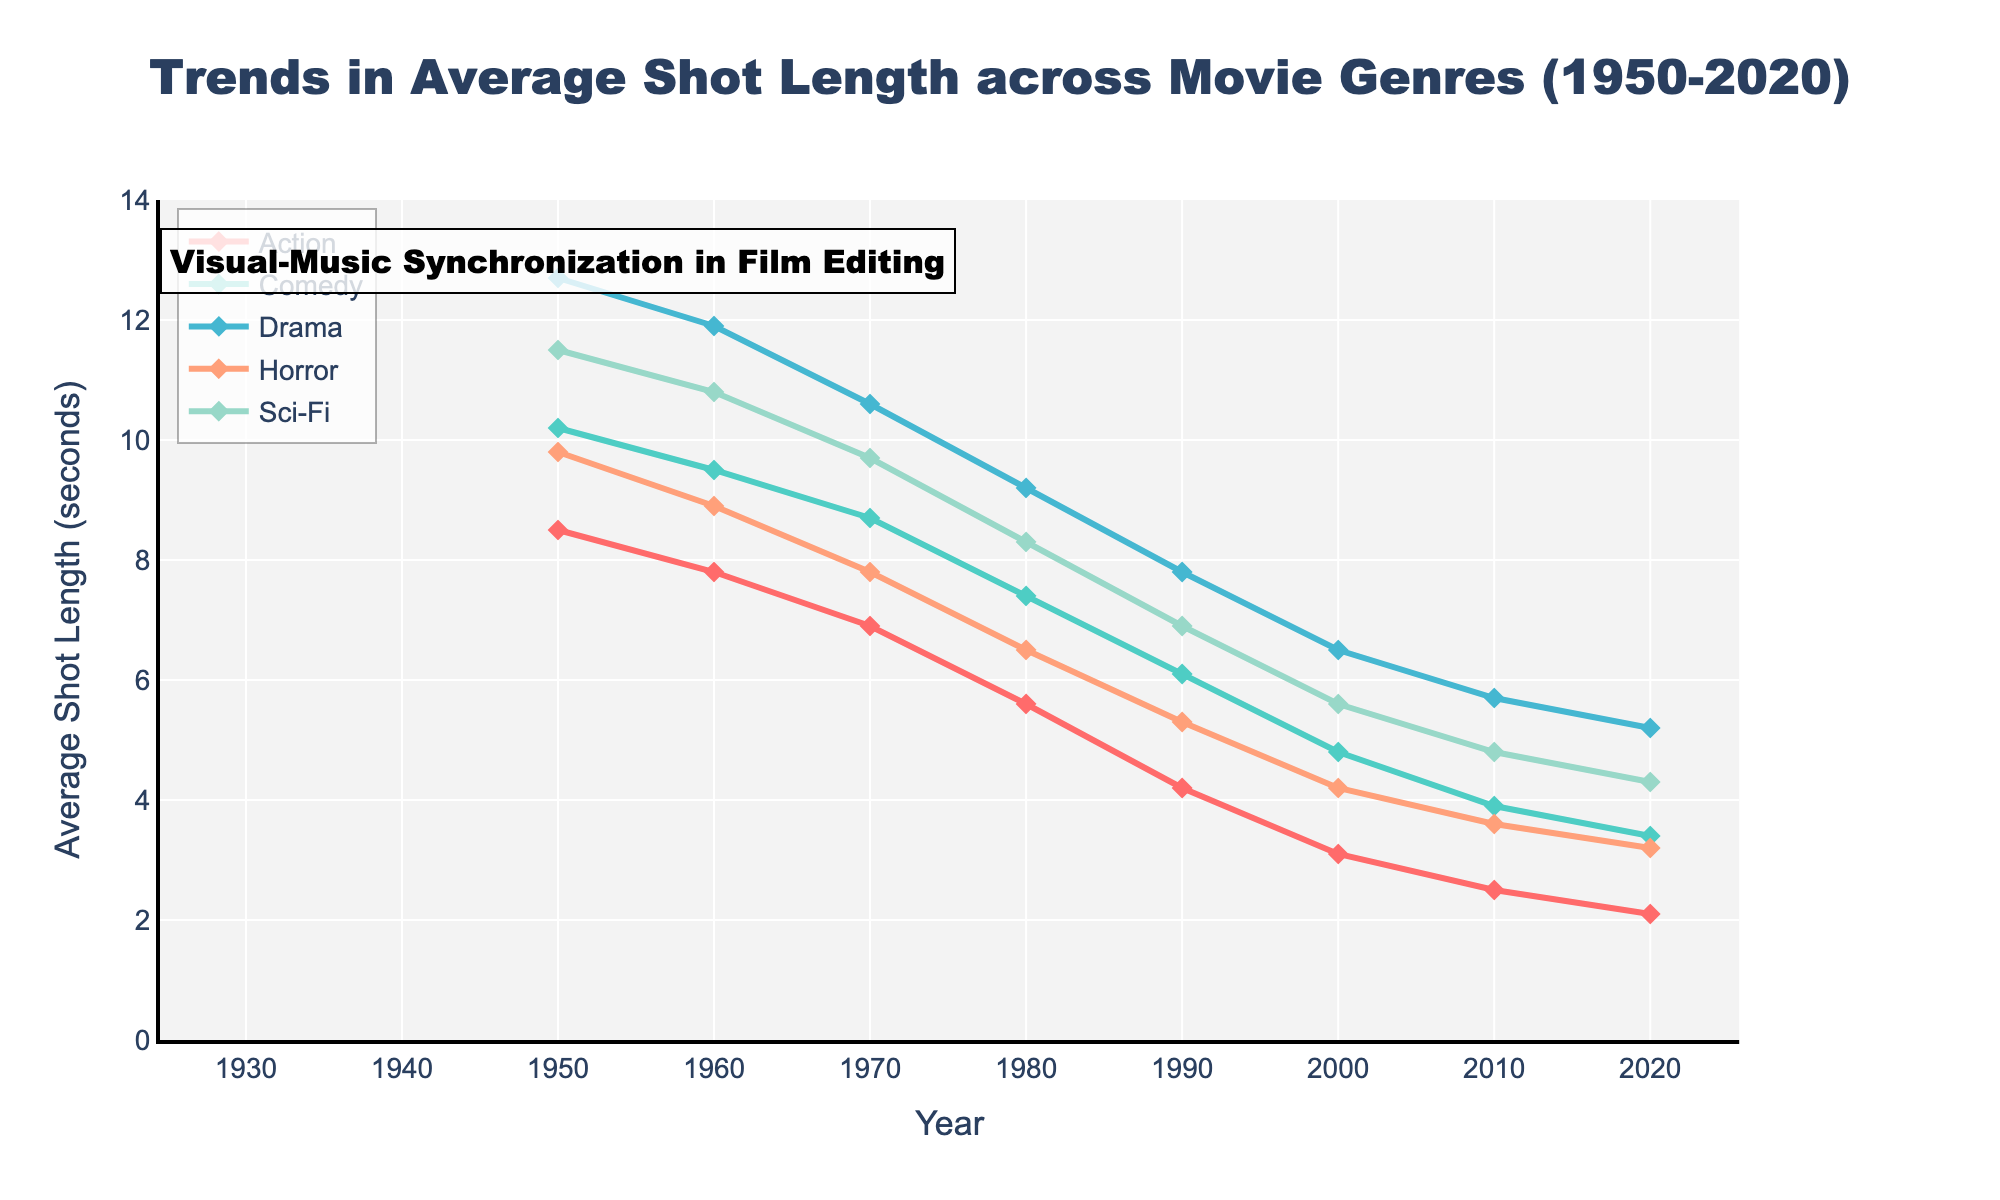How has the average shot length in Action movies changed from 1950 to 2020? From 1950 to 2020, the average shot length in Action movies has decreased from 8.5 seconds to 2.1 seconds. By subtracting the two values, we see a decline of 6.4 seconds.
Answer: Decreased by 6.4 seconds Which genre had the shortest average shot length in 2020? In 2020, the average shot length for Action movies was 2.1 seconds, whereas Comedy was 3.4, Drama was 5.2, Horror was 3.2, and Sci-Fi was 4.3 seconds. The shortest is 2.1 seconds in Action.
Answer: Action What is the difference in average shot length between Drama and Horror movies in 1990? In 1990, the average shot length for Drama movies was 7.8 seconds and for Horror movies, it was 5.3 seconds. The difference is 7.8 - 5.3 = 2.5 seconds.
Answer: 2.5 seconds What trend can you observe in the average shot length for Sci-Fi movies from 1950 to 2020? From 1950 to 2020, the average shot length for Sci-Fi movies has gradually decreased. Specifically, it has reduced from 11.5 seconds in 1950 to 4.3 seconds in 2020. The trend is a constant decline.
Answer: Decreasing trend Between 1950 and 2020, which genre experienced the largest reduction in average shot length? By calculating the difference for each genre from 1950 to 2020: 
- Action: 8.5 - 2.1 = 6.4 
- Comedy: 10.2 - 3.4 = 6.8
- Drama: 12.7 - 5.2 = 7.5 
- Horror: 9.8 - 3.2 = 6.6
- Sci-Fi: 11.5 - 4.3 = 7.2
Drama experienced the largest reduction of 7.5 seconds.
Answer: Drama What pattern do we notice about the average shot length across all genres from 1950 to 2020? A common pattern is that the average shot length in all genres has decreased over the years. This is observed as a downward trend in all the plotted lines.
Answer: Decreasing trend across all genres How does the average shot length of Comedy movies in 1980 compare to that in 2000? In 1980, the average shot length of Comedy movies was 7.4 seconds. In 2000, it was 4.8 seconds. Comparing the two, the shot length decreased from 7.4 to 4.8 seconds.
Answer: Decreased by 2.6 seconds Which genre had the longest average shot length in 1950, and how long was it? In 1950, Drama movies had the longest average shot length at 12.7 seconds, compared to Action (8.5), Comedy (10.2), Horror (9.8), and Sci-Fi (11.5).
Answer: Drama, 12.7 seconds 